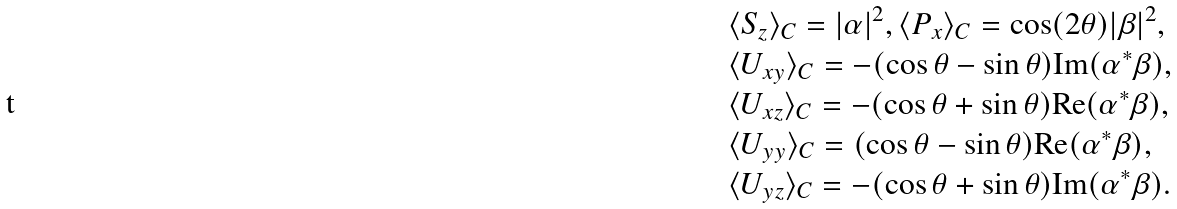<formula> <loc_0><loc_0><loc_500><loc_500>& \langle { S } _ { z } \rangle _ { C } = | \alpha | ^ { 2 } , \langle { P } _ { x } \rangle _ { C } = \cos ( 2 \theta ) | \beta | ^ { 2 } , \\ & \langle { U _ { x y } } \rangle _ { C } = - ( \cos \theta - \sin \theta ) \text {Im} ( \alpha ^ { * } \beta ) , \\ & \langle { U _ { x z } } \rangle _ { C } = - ( \cos \theta + \sin \theta ) \text {Re} ( \alpha ^ { * } \beta ) , \\ & \langle { U _ { y y } } \rangle _ { C } = ( \cos \theta - \sin \theta ) \text {Re} ( \alpha ^ { * } \beta ) , \\ & \langle { U _ { y z } } \rangle _ { C } = - ( \cos \theta + \sin \theta ) \text {Im} ( \alpha ^ { * } \beta ) . \\</formula> 